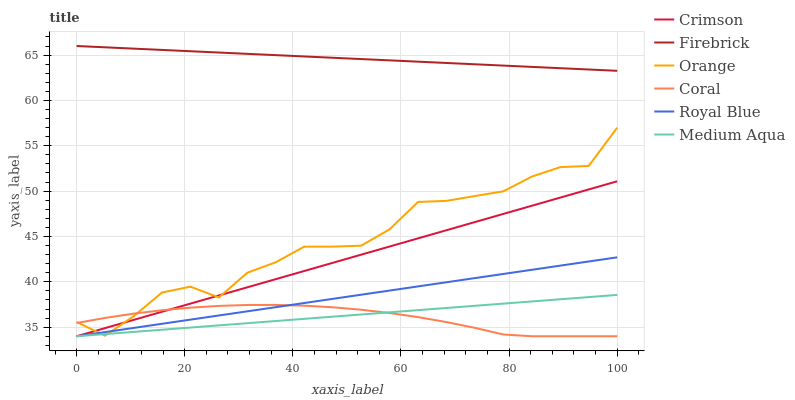Does Coral have the minimum area under the curve?
Answer yes or no. Yes. Does Firebrick have the maximum area under the curve?
Answer yes or no. Yes. Does Orange have the minimum area under the curve?
Answer yes or no. No. Does Orange have the maximum area under the curve?
Answer yes or no. No. Is Firebrick the smoothest?
Answer yes or no. Yes. Is Orange the roughest?
Answer yes or no. Yes. Is Orange the smoothest?
Answer yes or no. No. Is Firebrick the roughest?
Answer yes or no. No. Does Orange have the lowest value?
Answer yes or no. No. Does Firebrick have the highest value?
Answer yes or no. Yes. Does Orange have the highest value?
Answer yes or no. No. Is Royal Blue less than Firebrick?
Answer yes or no. Yes. Is Firebrick greater than Orange?
Answer yes or no. Yes. Does Coral intersect Medium Aqua?
Answer yes or no. Yes. Is Coral less than Medium Aqua?
Answer yes or no. No. Is Coral greater than Medium Aqua?
Answer yes or no. No. Does Royal Blue intersect Firebrick?
Answer yes or no. No. 